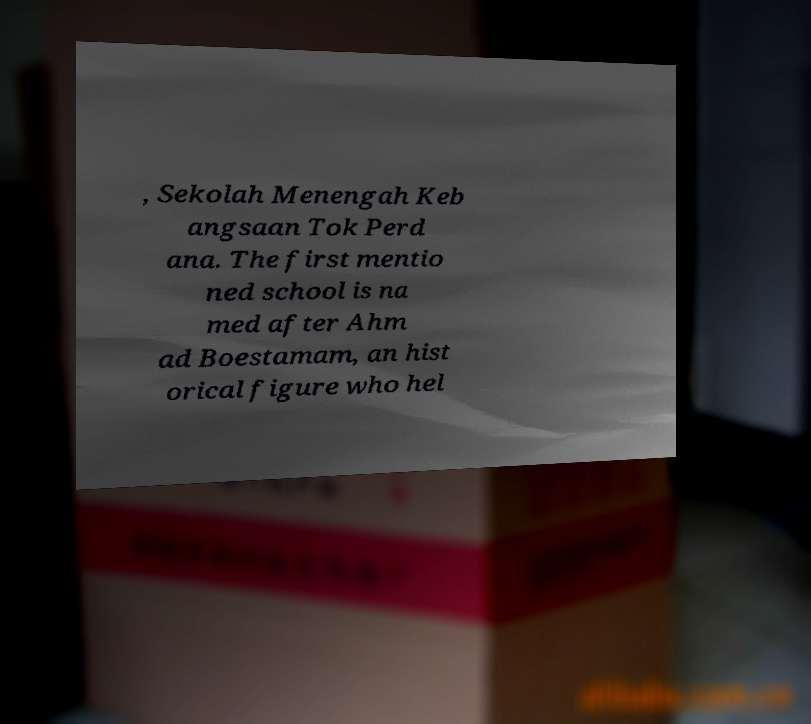Can you accurately transcribe the text from the provided image for me? , Sekolah Menengah Keb angsaan Tok Perd ana. The first mentio ned school is na med after Ahm ad Boestamam, an hist orical figure who hel 